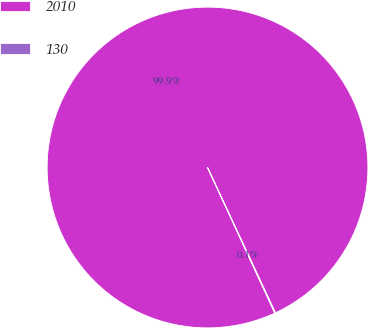Convert chart. <chart><loc_0><loc_0><loc_500><loc_500><pie_chart><fcel>2010<fcel>130<nl><fcel>99.92%<fcel>0.08%<nl></chart> 